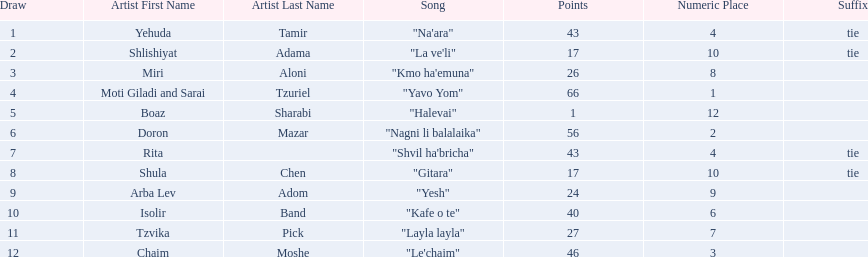What is the place of the contestant who received only 1 point? 12th. What is the name of the artist listed in the previous question? Boaz Sharabi. Parse the table in full. {'header': ['Draw', 'Artist First Name', 'Artist Last Name', 'Song', 'Points', 'Numeric Place', 'Suffix'], 'rows': [['1', 'Yehuda', 'Tamir', '"Na\'ara"', '43', '4', 'tie'], ['2', 'Shlishiyat', 'Adama', '"La ve\'li"', '17', '10', 'tie'], ['3', 'Miri', 'Aloni', '"Kmo ha\'emuna"', '26', '8', ''], ['4', 'Moti Giladi and Sarai', 'Tzuriel', '"Yavo Yom"', '66', '1', ''], ['5', 'Boaz', 'Sharabi', '"Halevai"', '1', '12', ''], ['6', 'Doron', 'Mazar', '"Nagni li balalaika"', '56', '2', ''], ['7', 'Rita', '', '"Shvil ha\'bricha"', '43', '4', 'tie'], ['8', 'Shula', 'Chen', '"Gitara"', '17', '10', 'tie'], ['9', 'Arba Lev', 'Adom', '"Yesh"', '24', '9', ''], ['10', 'Isolir', 'Band', '"Kafe o te"', '40', '6', ''], ['11', 'Tzvika', 'Pick', '"Layla layla"', '27', '7', ''], ['12', 'Chaim', 'Moshe', '"Le\'chaim"', '46', '3', '']]} 